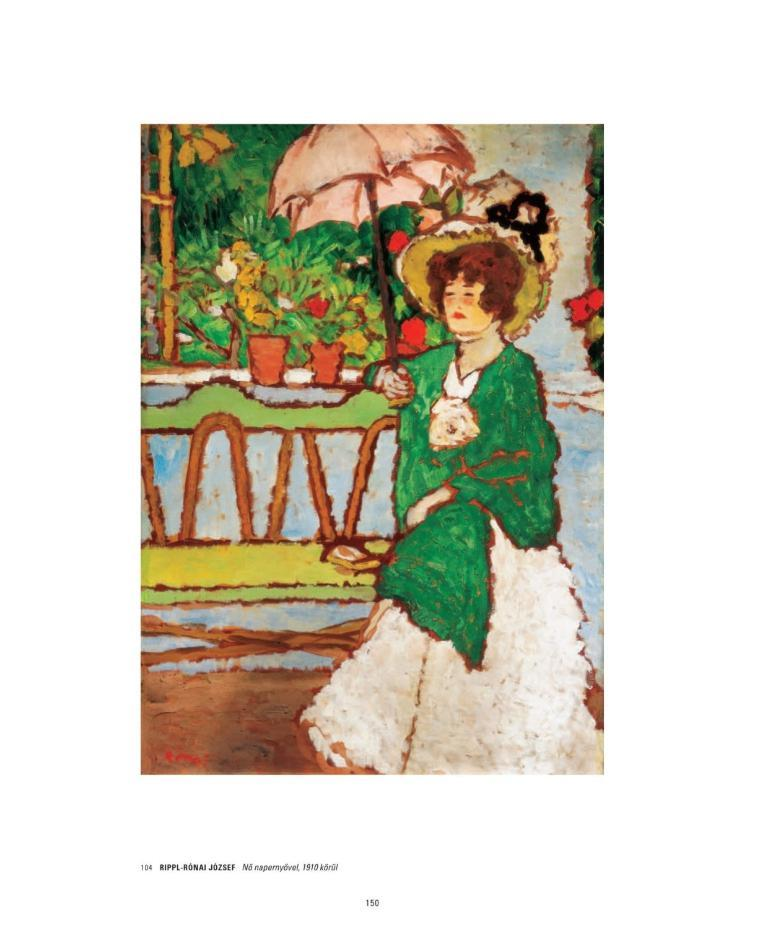What is depicted in the painting in the image? There is a painting of a woman in the image. What is the woman doing in the painting? The woman is sitting on a bench in the painting. What is the woman holding in her right hand? The woman is holding an umbrella in her right hand. What can be seen in the image besides the painting? There are flower pots and plants in the image. What month is it in the image? The month is not mentioned or depicted in the image, so it cannot be determined. 